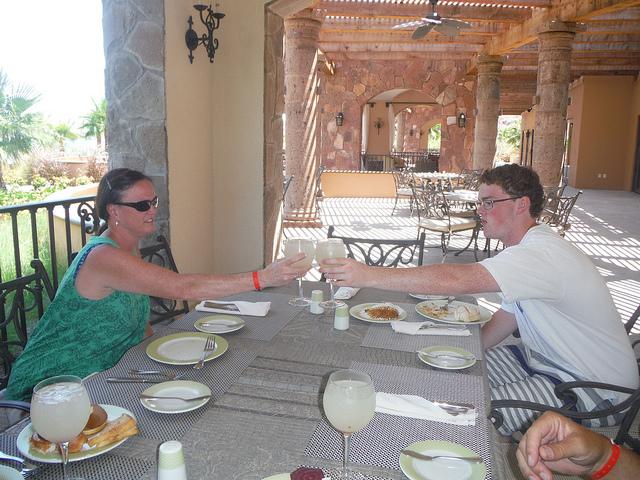Are they cutting a cake?
Be succinct. No. Where are the plates?
Write a very short answer. Table. Are the people toasting?
Answer briefly. Yes. What season is it?
Short answer required. Summer. 